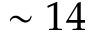<formula> <loc_0><loc_0><loc_500><loc_500>\sim 1 4</formula> 